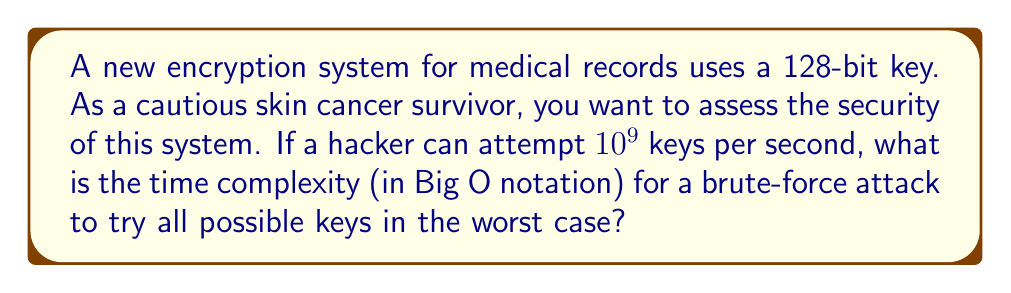Provide a solution to this math problem. Let's approach this step-by-step:

1) First, we need to calculate the total number of possible keys:
   With a 128-bit key, there are $2^{128}$ possible combinations.

2) Now, let's consider the rate at which keys can be attempted:
   The hacker can try $10^9$ keys per second.

3) To find the total time needed, we divide the number of possible keys by the rate:
   Time = $\frac{2^{128}}{10^9}$ seconds

4) In Big O notation, we're interested in the order of growth. Constants and lower-order terms are ignored.

5) $2^{128}$ is much larger than $10^9$, so the denominator becomes insignificant in terms of order of growth.

6) Therefore, the time complexity is proportional to the number of possible keys: $O(2^{128})$

7) In Big O notation, we typically express exponentials with base 2, so this is our final answer.
Answer: $O(2^{128})$ 